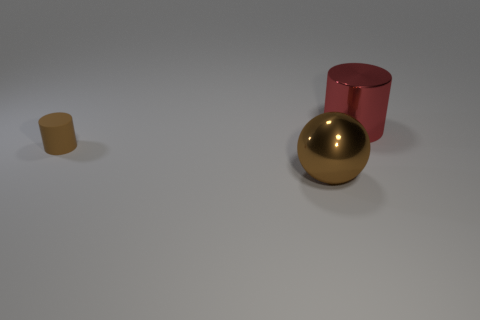Add 2 rubber cubes. How many objects exist? 5 Subtract all brown cylinders. How many cylinders are left? 1 Subtract all spheres. How many objects are left? 2 Subtract all red cylinders. Subtract all brown blocks. How many cylinders are left? 1 Subtract all brown cubes. How many brown cylinders are left? 1 Subtract all large brown metallic cylinders. Subtract all metallic things. How many objects are left? 1 Add 2 red shiny cylinders. How many red shiny cylinders are left? 3 Add 1 cylinders. How many cylinders exist? 3 Subtract 0 yellow cylinders. How many objects are left? 3 Subtract 2 cylinders. How many cylinders are left? 0 